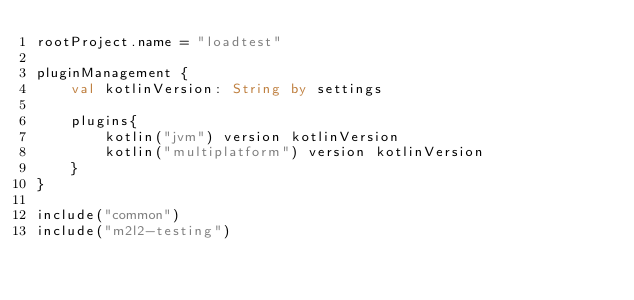Convert code to text. <code><loc_0><loc_0><loc_500><loc_500><_Kotlin_>rootProject.name = "loadtest"

pluginManagement {
    val kotlinVersion: String by settings

    plugins{
        kotlin("jvm") version kotlinVersion
        kotlin("multiplatform") version kotlinVersion
    }
}

include("common")
include("m2l2-testing")
</code> 